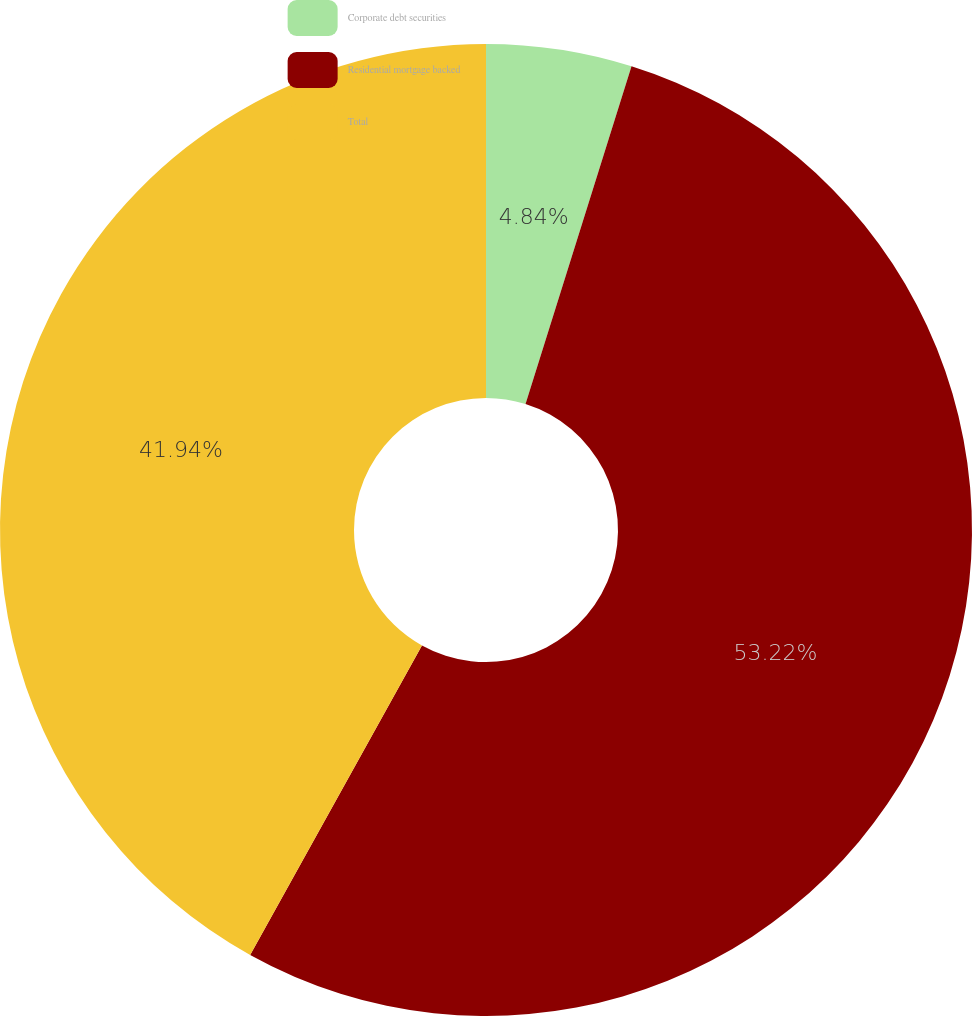Convert chart to OTSL. <chart><loc_0><loc_0><loc_500><loc_500><pie_chart><fcel>Corporate debt securities<fcel>Residential mortgage backed<fcel>Total<nl><fcel>4.84%<fcel>53.23%<fcel>41.94%<nl></chart> 